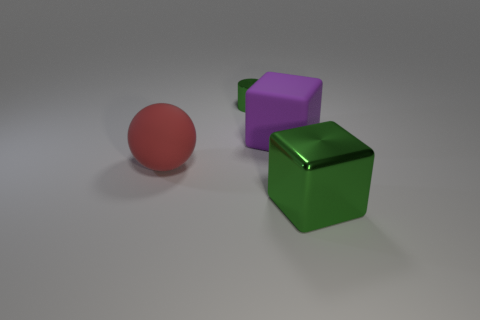Are the shadows that the objects cast consistent with a single light source? Yes, the shadows cast by the green metallic cube, red sphere, and purple cube are aligned in the same direction, which suggests these objects are illuminated by a single light source. 